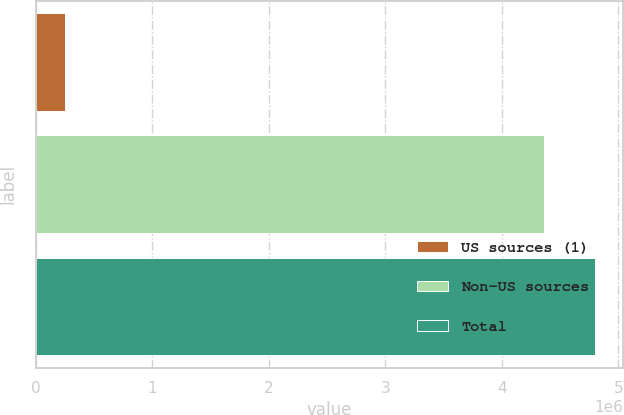<chart> <loc_0><loc_0><loc_500><loc_500><bar_chart><fcel>US sources (1)<fcel>Non-US sources<fcel>Total<nl><fcel>251456<fcel>4.36458e+06<fcel>4.80103e+06<nl></chart> 